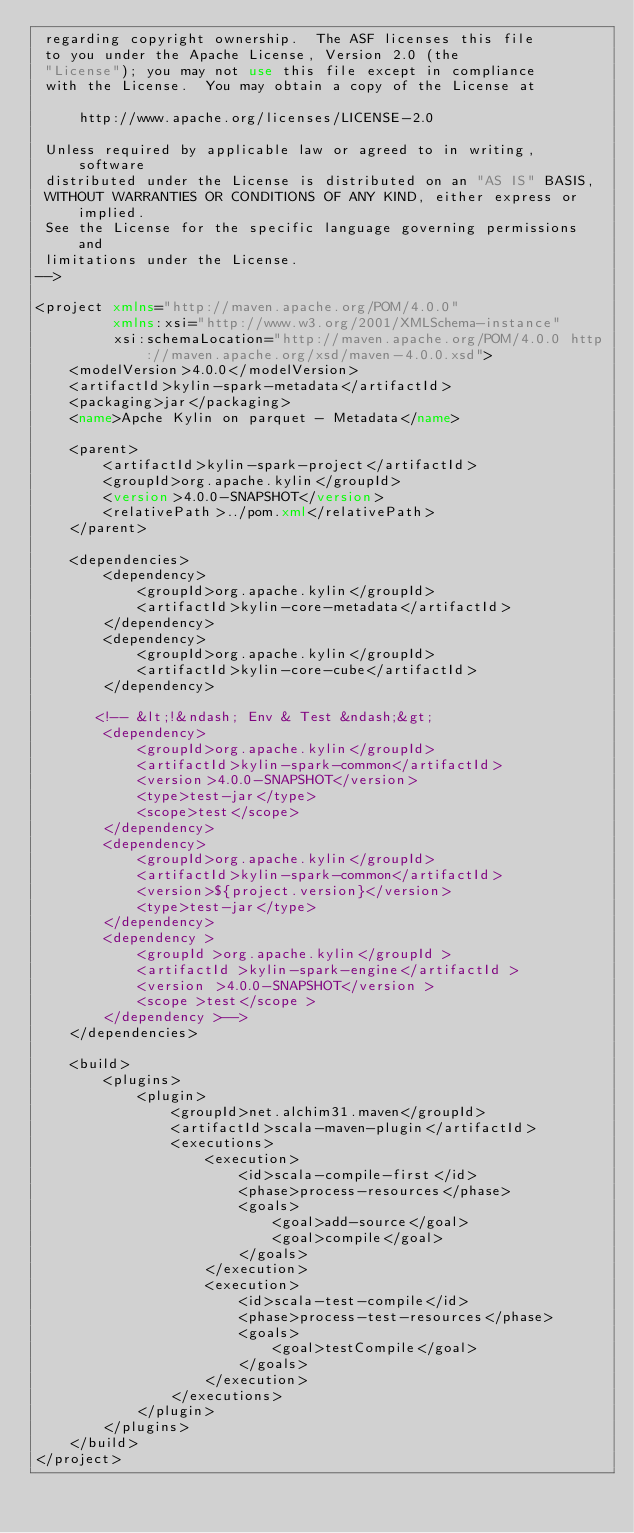<code> <loc_0><loc_0><loc_500><loc_500><_XML_> regarding copyright ownership.  The ASF licenses this file
 to you under the Apache License, Version 2.0 (the
 "License"); you may not use this file except in compliance
 with the License.  You may obtain a copy of the License at

     http://www.apache.org/licenses/LICENSE-2.0

 Unless required by applicable law or agreed to in writing, software
 distributed under the License is distributed on an "AS IS" BASIS,
 WITHOUT WARRANTIES OR CONDITIONS OF ANY KIND, either express or implied.
 See the License for the specific language governing permissions and
 limitations under the License.
-->

<project xmlns="http://maven.apache.org/POM/4.0.0"
         xmlns:xsi="http://www.w3.org/2001/XMLSchema-instance"
         xsi:schemaLocation="http://maven.apache.org/POM/4.0.0 http://maven.apache.org/xsd/maven-4.0.0.xsd">
    <modelVersion>4.0.0</modelVersion>
    <artifactId>kylin-spark-metadata</artifactId>
    <packaging>jar</packaging>
    <name>Apche Kylin on parquet - Metadata</name>

    <parent>
        <artifactId>kylin-spark-project</artifactId>
        <groupId>org.apache.kylin</groupId>
        <version>4.0.0-SNAPSHOT</version>
        <relativePath>../pom.xml</relativePath>
    </parent>

    <dependencies>
        <dependency>
            <groupId>org.apache.kylin</groupId>
            <artifactId>kylin-core-metadata</artifactId>
        </dependency>
        <dependency>
            <groupId>org.apache.kylin</groupId>
            <artifactId>kylin-core-cube</artifactId>
        </dependency>

       <!-- &lt;!&ndash; Env & Test &ndash;&gt;
        <dependency>
            <groupId>org.apache.kylin</groupId>
            <artifactId>kylin-spark-common</artifactId>
            <version>4.0.0-SNAPSHOT</version>
            <type>test-jar</type>
            <scope>test</scope>
        </dependency>
        <dependency>
            <groupId>org.apache.kylin</groupId>
            <artifactId>kylin-spark-common</artifactId>
            <version>${project.version}</version>
            <type>test-jar</type>
        </dependency>
        <dependency >
            <groupId >org.apache.kylin</groupId >
            <artifactId >kylin-spark-engine</artifactId >
            <version >4.0.0-SNAPSHOT</version >
            <scope >test</scope >
        </dependency >-->
    </dependencies>

    <build>
        <plugins>
            <plugin>
                <groupId>net.alchim31.maven</groupId>
                <artifactId>scala-maven-plugin</artifactId>
                <executions>
                    <execution>
                        <id>scala-compile-first</id>
                        <phase>process-resources</phase>
                        <goals>
                            <goal>add-source</goal>
                            <goal>compile</goal>
                        </goals>
                    </execution>
                    <execution>
                        <id>scala-test-compile</id>
                        <phase>process-test-resources</phase>
                        <goals>
                            <goal>testCompile</goal>
                        </goals>
                    </execution>
                </executions>
            </plugin>
        </plugins>
    </build>
</project></code> 